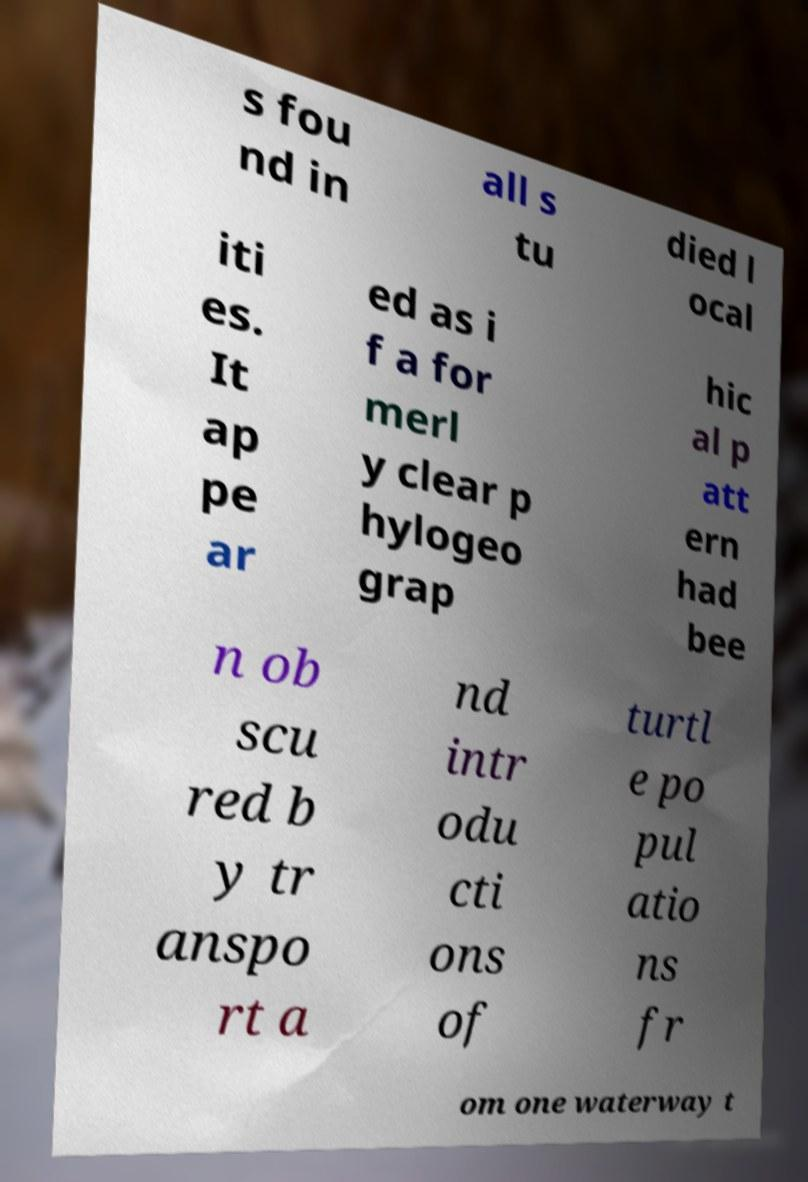What messages or text are displayed in this image? I need them in a readable, typed format. s fou nd in all s tu died l ocal iti es. It ap pe ar ed as i f a for merl y clear p hylogeo grap hic al p att ern had bee n ob scu red b y tr anspo rt a nd intr odu cti ons of turtl e po pul atio ns fr om one waterway t 